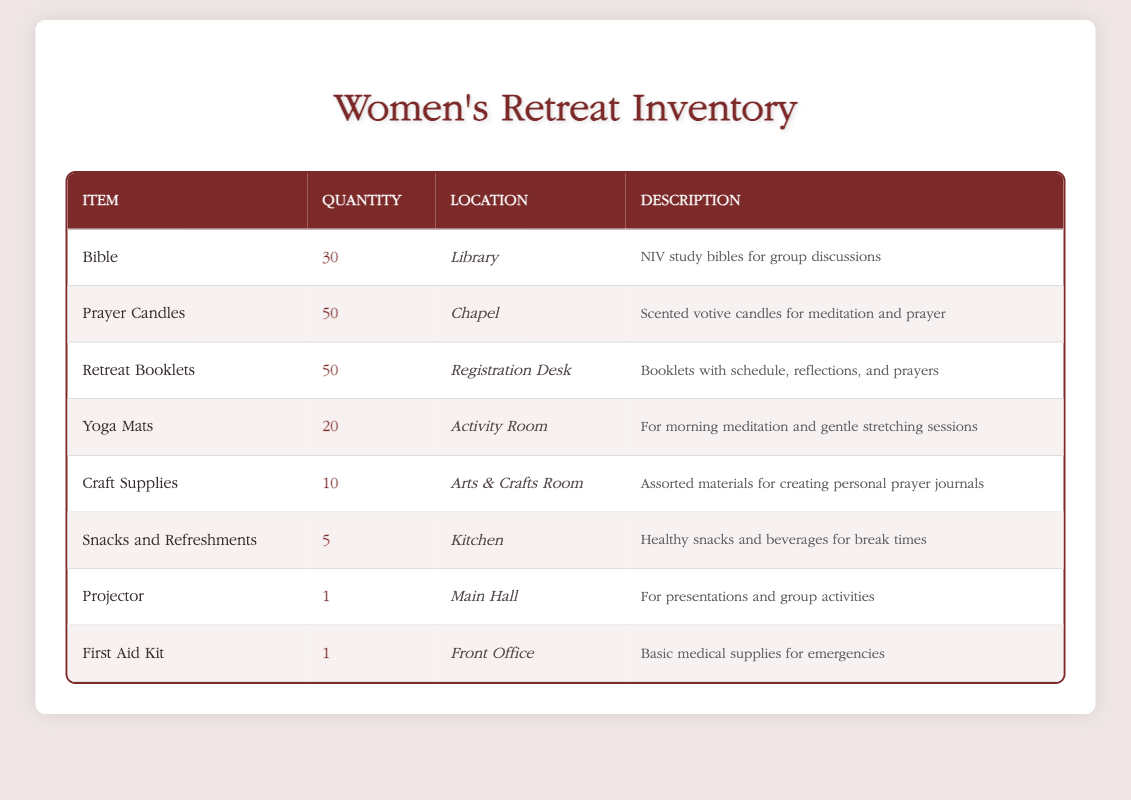What is the total quantity of Prayer Candles and Retreat Booklets combined? The quantity of Prayer Candles is 50, and the quantity of Retreat Booklets is also 50. Adding these quantities together gives us 50 + 50 = 100.
Answer: 100 How many items in total are stored in the Library? The only item listed under the Library is the Bible, with a quantity of 30. Therefore, the total number of items in the Library is simply 30.
Answer: 30 Is there more quantity of Yoga Mats or Craft Supplies? The quantity of Yoga Mats is 20, and the quantity of Craft Supplies is 10. Since 20 is greater than 10, there are more Yoga Mats than Craft Supplies.
Answer: Yes Where is the Projector located? The table specifies that the Projector is located in the Main Hall. By finding the row with Projector, we note its location clearly stated.
Answer: Main Hall What is the total number of First Aid Kits and Projectors available? There is 1 First Aid Kit and 1 Projector listed in the table. Adding these quantities gives us 1 + 1 = 2.
Answer: 2 Are there any items in the Kitchen with a quantity of more than 5? The item listed in the Kitchen is Snacks and Refreshments, and it has a quantity of 5. Since the quantity is not greater than 5, this statement is false.
Answer: No Which location has the most items available? The items listed are as follows: Library has 30 Bibles, Chapel has 50 Prayer Candles, Registration Desk has 50 Retreat Booklets, Activity Room has 20 Yoga Mats, Arts & Crafts Room has 10 Craft Supplies, Kitchen has 5 Snacks, Main Hall has 1 Projector, and Front Office has 1 First Aid Kit. The largest quantities are at the Chapel and Registration Desk, both at 50, making them tied for the most items.
Answer: Chapel and Registration Desk How many fewer Yoga Mats are there compared to Prayer Candles? The quantity of Yoga Mats is 20, and the quantity of Prayer Candles is 50. To find the difference, we subtract the quantity of Yoga Mats from that of Prayer Candles: 50 - 20 = 30.
Answer: 30 